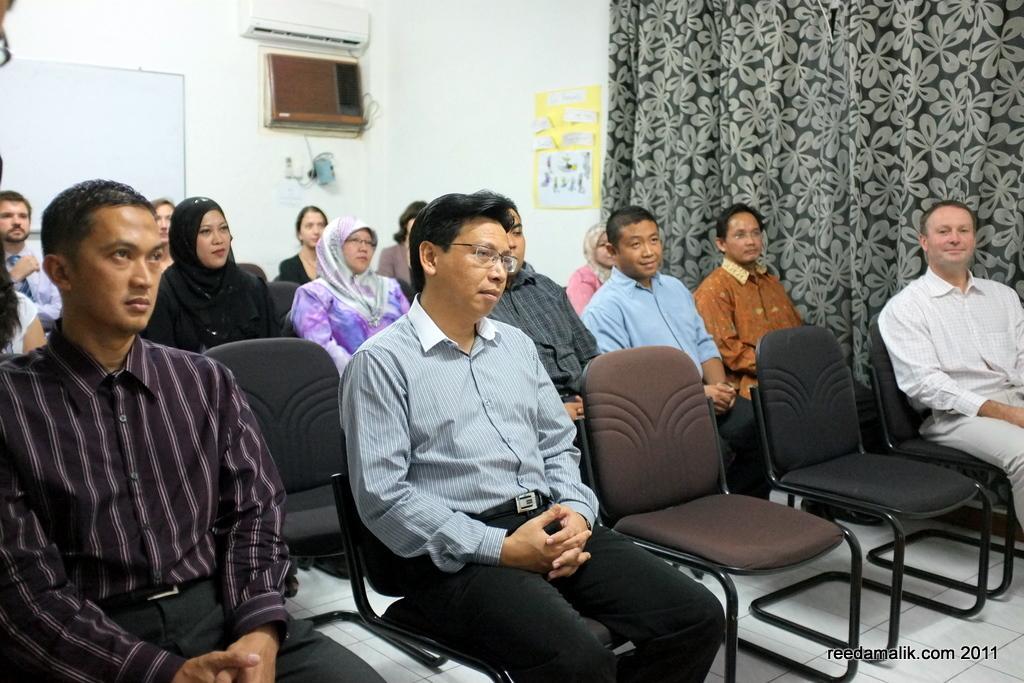Describe this image in one or two sentences. In this image there are some peoples sitting on the chairs and in the background there is a wall of white color and a board of white color is placed on the wall and there is a Ac on the on the wall which is in white color and a wall beside that which is covered by a black curtain. 